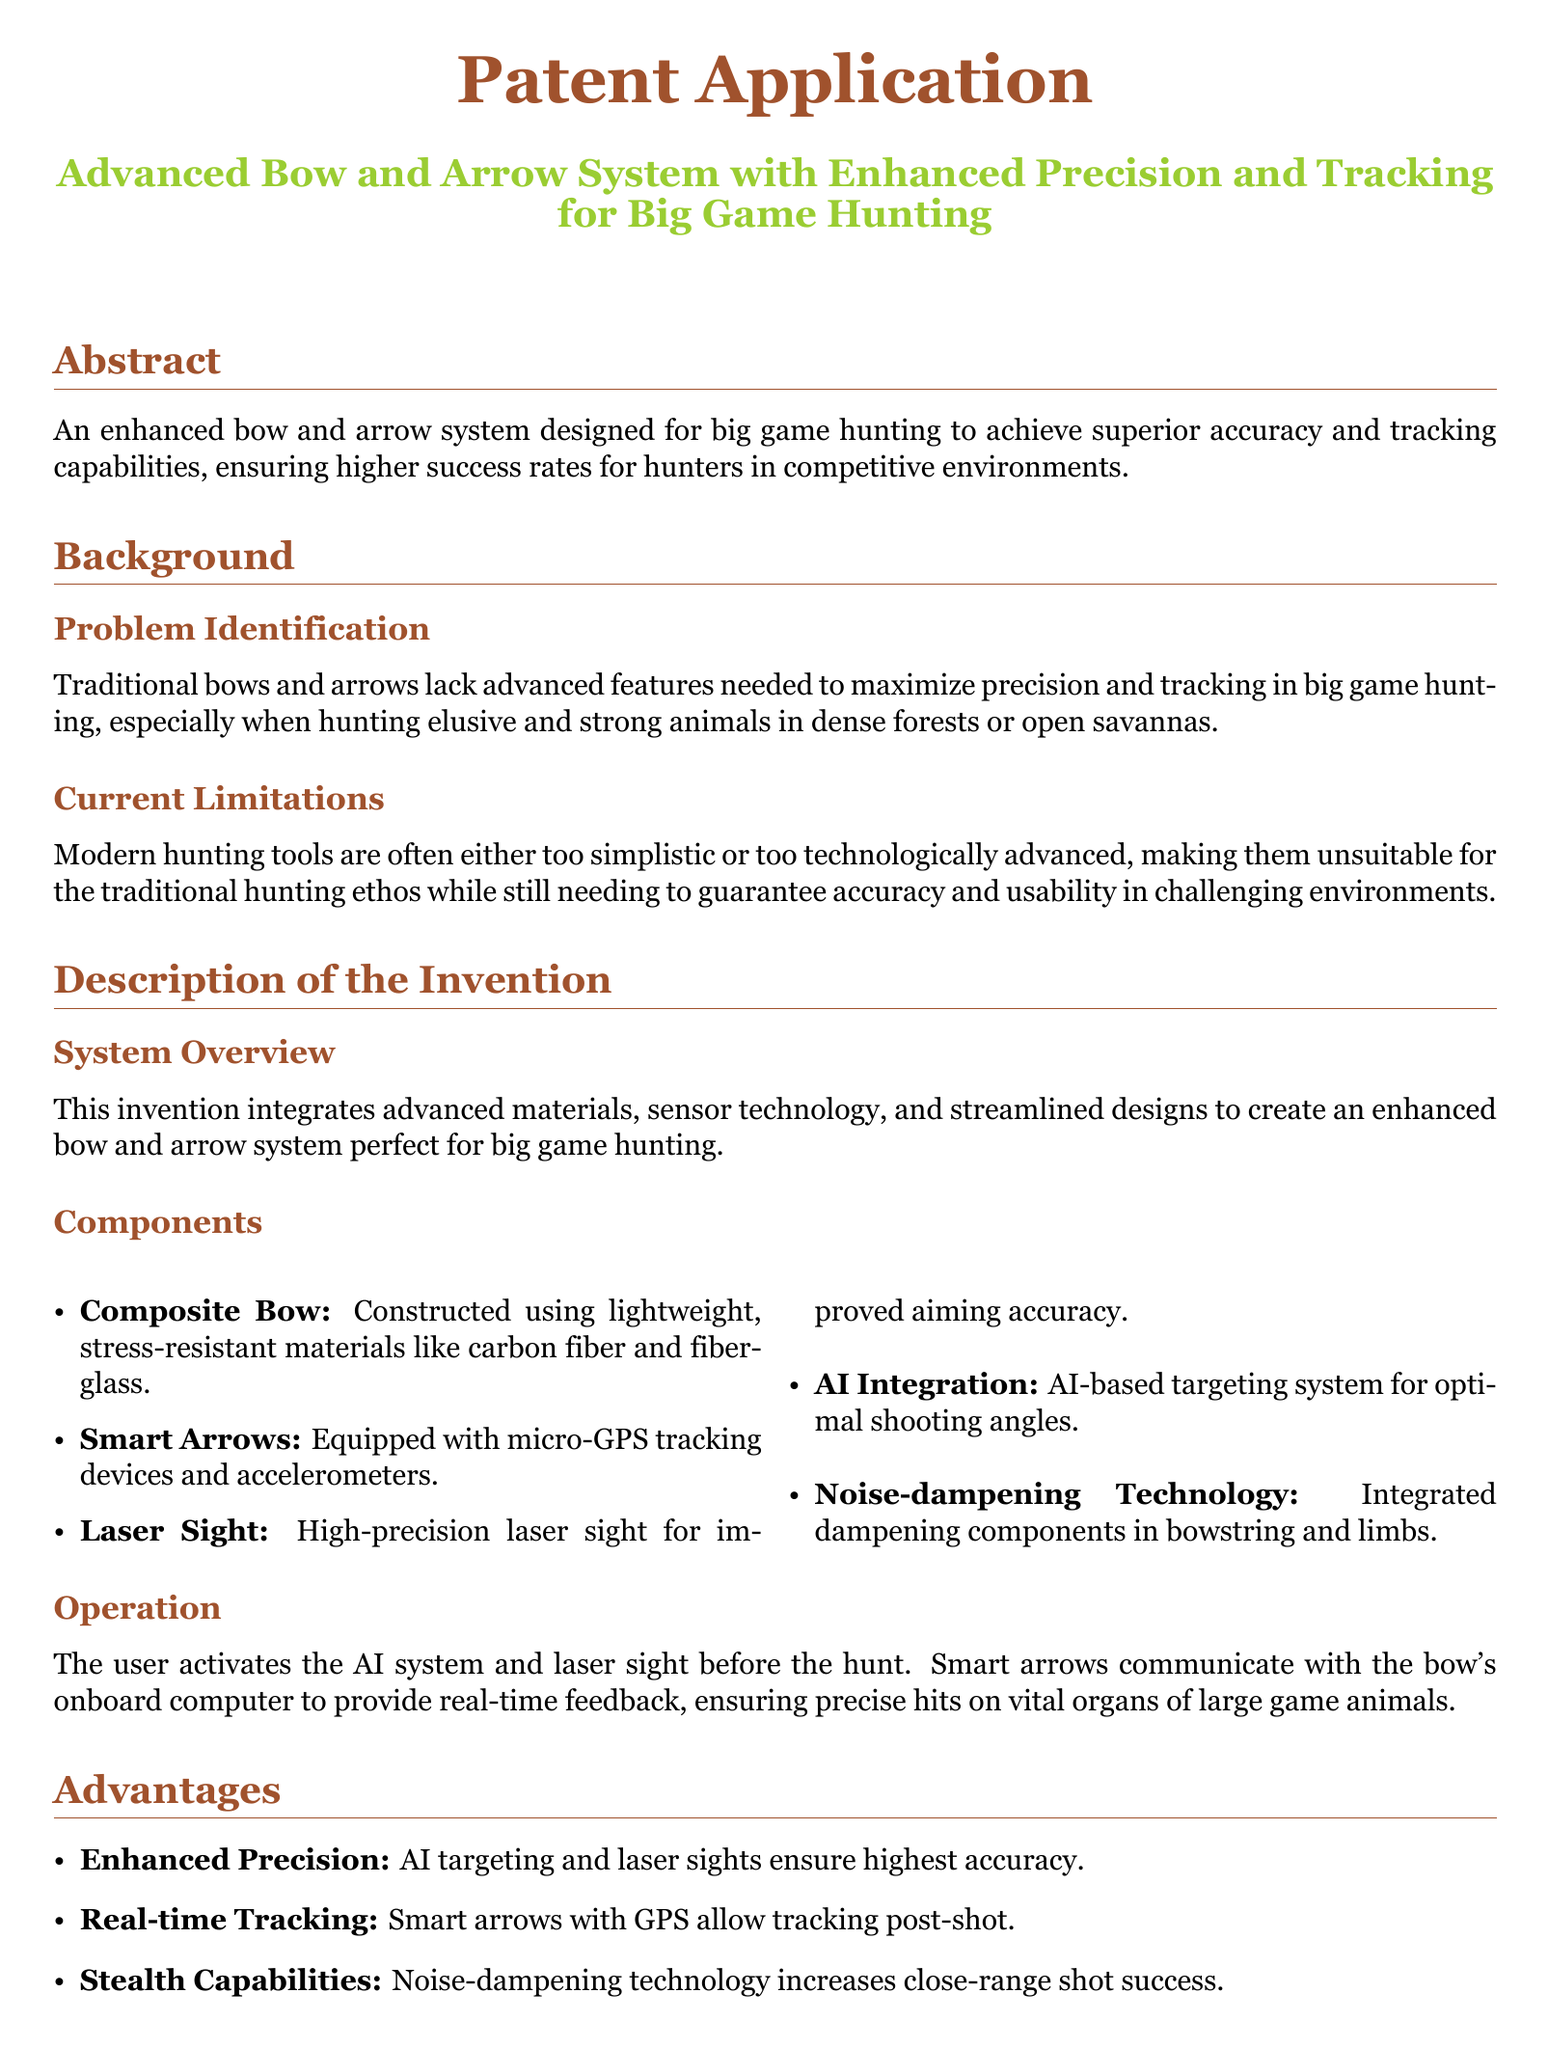What is the title of the invention? The title is the heading of the document that describes the invention being patented.
Answer: Advanced Bow and Arrow System with Enhanced Precision and Tracking for Big Game Hunting Who is the inventor of the system? The inventor's name is listed as the person submitting the patent application.
Answer: A fellow lion hunter What materials are used for the composite bow? The materials are specifically mentioned in the component description of the invention.
Answer: Carbon fiber and fiberglass What technology do the smart arrows use? The document describes the functionality of the smart arrows in the components section.
Answer: Micro-GPS tracking devices and accelerometers What is the primary purpose of the laser sight? The purpose is outlined in the advantages section of the invention.
Answer: Improved aiming accuracy How does the AI integration assist the user? The AI integration is mentioned in the operation section, explaining its role during hunting.
Answer: Optimal shooting angles What are the advantages of using noise-dampening technology? The advantages are listed in the advantages section, detailing its benefits for hunters.
Answer: Increases close-range shot success How many claims are made in the patent application? The total number of claims can be found in the claims section of the document.
Answer: Five claims 